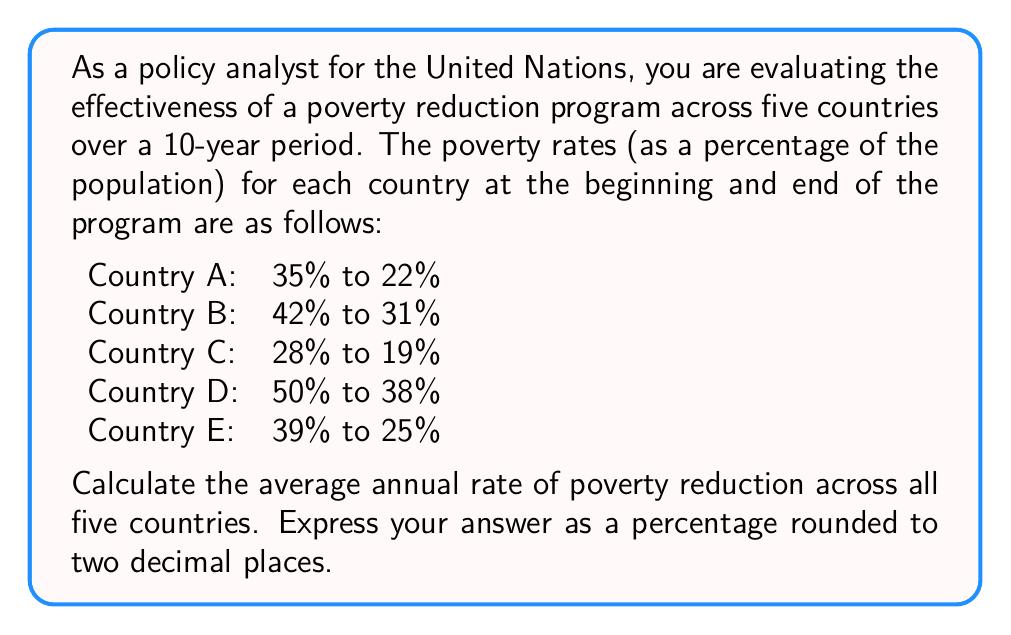Give your solution to this math problem. To solve this problem, we'll follow these steps:

1. Calculate the total reduction in poverty rate for each country
2. Calculate the annual rate of reduction for each country
3. Find the average of the annual rates across all countries

Step 1: Calculate the total reduction in poverty rate

For each country, we subtract the final rate from the initial rate:

Country A: $35\% - 22\% = 13\%$
Country B: $42\% - 31\% = 11\%$
Country C: $28\% - 19\% = 9\%$
Country D: $50\% - 38\% = 12\%$
Country E: $39\% - 25\% = 14\%$

Step 2: Calculate the annual rate of reduction

To find the annual rate, we divide the total reduction by the number of years (10):

Country A: $\frac{13\%}{10} = 1.3\%$ per year
Country B: $\frac{11\%}{10} = 1.1\%$ per year
Country C: $\frac{9\%}{10} = 0.9\%$ per year
Country D: $\frac{12\%}{10} = 1.2\%$ per year
Country E: $\frac{14\%}{10} = 1.4\%$ per year

Step 3: Find the average of the annual rates

To calculate the average, we sum all the annual rates and divide by the number of countries:

$$\text{Average annual rate} = \frac{1.3\% + 1.1\% + 0.9\% + 1.2\% + 1.4\%}{5}$$

$$= \frac{5.9\%}{5} = 1.18\%$$

Rounding to two decimal places, we get 1.18%.
Answer: The average annual rate of poverty reduction across all five countries is 1.18%. 